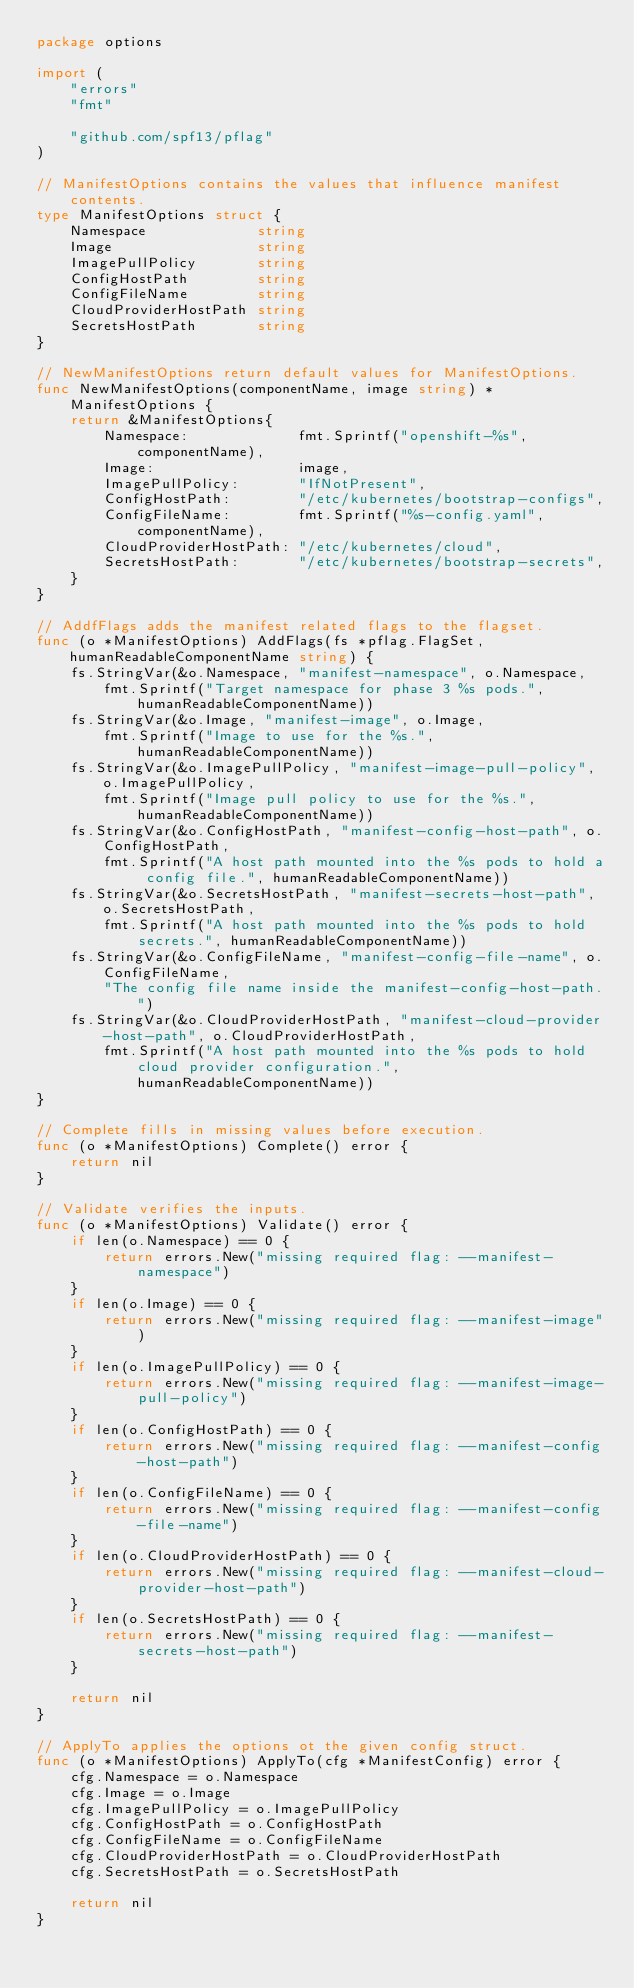Convert code to text. <code><loc_0><loc_0><loc_500><loc_500><_Go_>package options

import (
	"errors"
	"fmt"

	"github.com/spf13/pflag"
)

// ManifestOptions contains the values that influence manifest contents.
type ManifestOptions struct {
	Namespace             string
	Image                 string
	ImagePullPolicy       string
	ConfigHostPath        string
	ConfigFileName        string
	CloudProviderHostPath string
	SecretsHostPath       string
}

// NewManifestOptions return default values for ManifestOptions.
func NewManifestOptions(componentName, image string) *ManifestOptions {
	return &ManifestOptions{
		Namespace:             fmt.Sprintf("openshift-%s", componentName),
		Image:                 image,
		ImagePullPolicy:       "IfNotPresent",
		ConfigHostPath:        "/etc/kubernetes/bootstrap-configs",
		ConfigFileName:        fmt.Sprintf("%s-config.yaml", componentName),
		CloudProviderHostPath: "/etc/kubernetes/cloud",
		SecretsHostPath:       "/etc/kubernetes/bootstrap-secrets",
	}
}

// AddfFlags adds the manifest related flags to the flagset.
func (o *ManifestOptions) AddFlags(fs *pflag.FlagSet, humanReadableComponentName string) {
	fs.StringVar(&o.Namespace, "manifest-namespace", o.Namespace,
		fmt.Sprintf("Target namespace for phase 3 %s pods.", humanReadableComponentName))
	fs.StringVar(&o.Image, "manifest-image", o.Image,
		fmt.Sprintf("Image to use for the %s.", humanReadableComponentName))
	fs.StringVar(&o.ImagePullPolicy, "manifest-image-pull-policy", o.ImagePullPolicy,
		fmt.Sprintf("Image pull policy to use for the %s.", humanReadableComponentName))
	fs.StringVar(&o.ConfigHostPath, "manifest-config-host-path", o.ConfigHostPath,
		fmt.Sprintf("A host path mounted into the %s pods to hold a config file.", humanReadableComponentName))
	fs.StringVar(&o.SecretsHostPath, "manifest-secrets-host-path", o.SecretsHostPath,
		fmt.Sprintf("A host path mounted into the %s pods to hold secrets.", humanReadableComponentName))
	fs.StringVar(&o.ConfigFileName, "manifest-config-file-name", o.ConfigFileName,
		"The config file name inside the manifest-config-host-path.")
	fs.StringVar(&o.CloudProviderHostPath, "manifest-cloud-provider-host-path", o.CloudProviderHostPath,
		fmt.Sprintf("A host path mounted into the %s pods to hold cloud provider configuration.", humanReadableComponentName))
}

// Complete fills in missing values before execution.
func (o *ManifestOptions) Complete() error {
	return nil
}

// Validate verifies the inputs.
func (o *ManifestOptions) Validate() error {
	if len(o.Namespace) == 0 {
		return errors.New("missing required flag: --manifest-namespace")
	}
	if len(o.Image) == 0 {
		return errors.New("missing required flag: --manifest-image")
	}
	if len(o.ImagePullPolicy) == 0 {
		return errors.New("missing required flag: --manifest-image-pull-policy")
	}
	if len(o.ConfigHostPath) == 0 {
		return errors.New("missing required flag: --manifest-config-host-path")
	}
	if len(o.ConfigFileName) == 0 {
		return errors.New("missing required flag: --manifest-config-file-name")
	}
	if len(o.CloudProviderHostPath) == 0 {
		return errors.New("missing required flag: --manifest-cloud-provider-host-path")
	}
	if len(o.SecretsHostPath) == 0 {
		return errors.New("missing required flag: --manifest-secrets-host-path")
	}

	return nil
}

// ApplyTo applies the options ot the given config struct.
func (o *ManifestOptions) ApplyTo(cfg *ManifestConfig) error {
	cfg.Namespace = o.Namespace
	cfg.Image = o.Image
	cfg.ImagePullPolicy = o.ImagePullPolicy
	cfg.ConfigHostPath = o.ConfigHostPath
	cfg.ConfigFileName = o.ConfigFileName
	cfg.CloudProviderHostPath = o.CloudProviderHostPath
	cfg.SecretsHostPath = o.SecretsHostPath

	return nil
}
</code> 